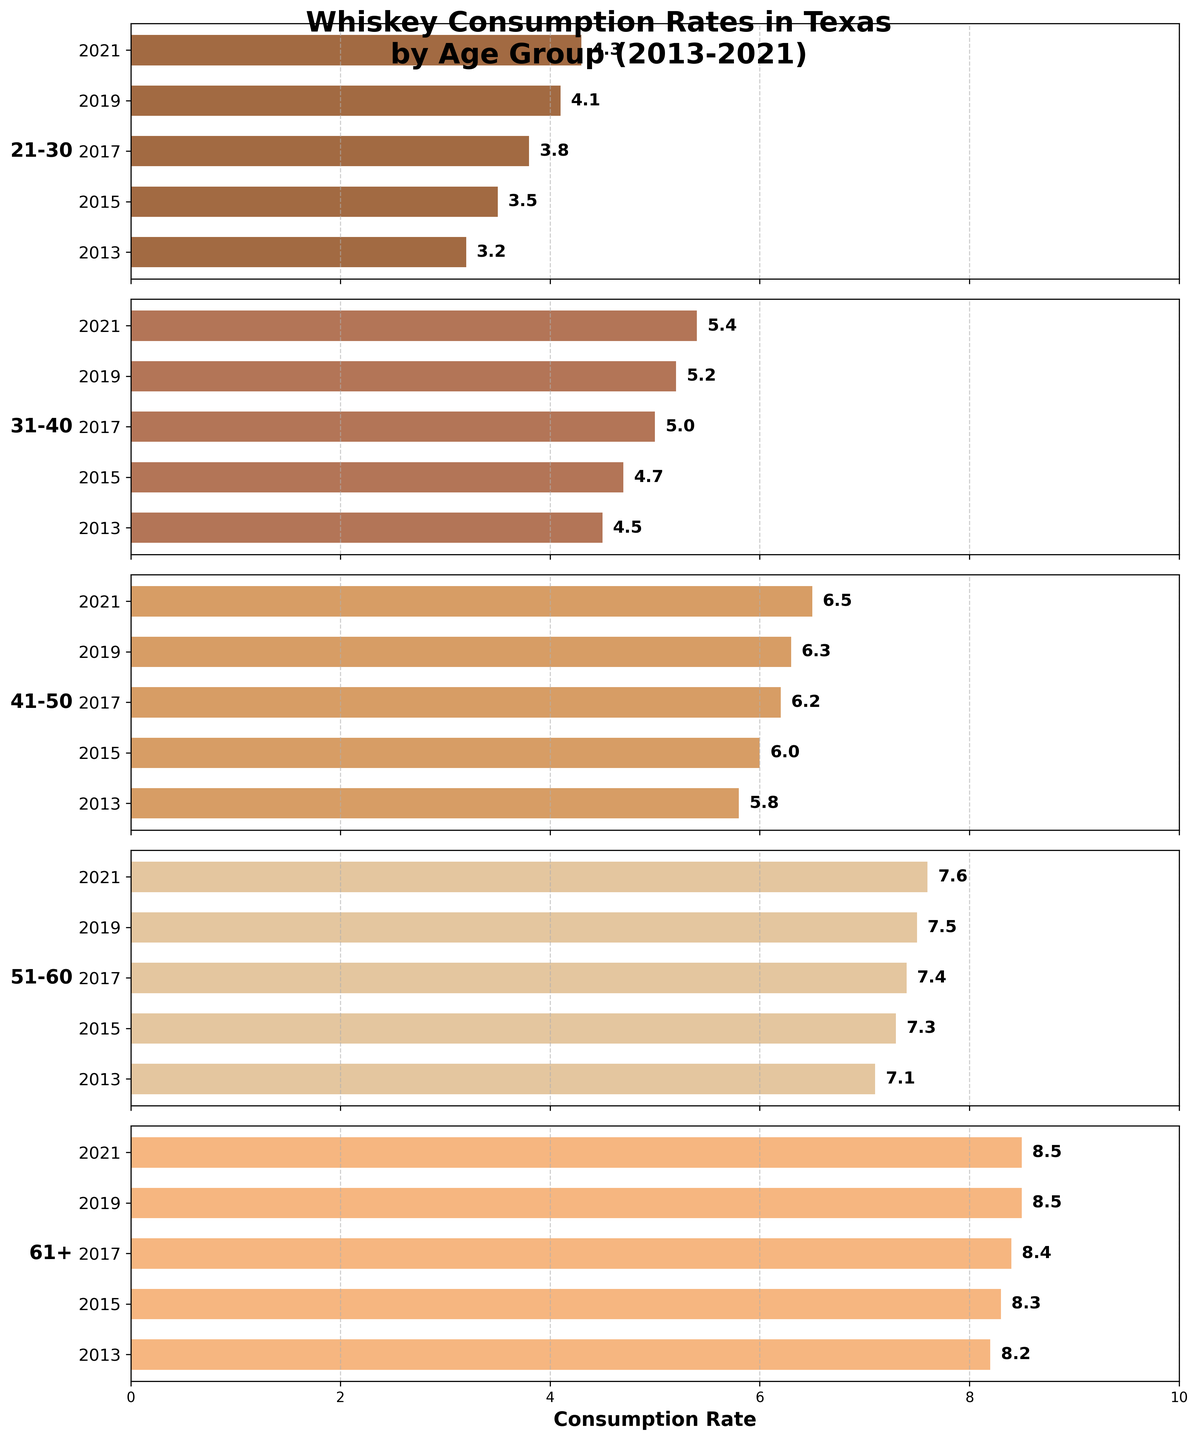What's the title of the figure? The title is displayed at the top of the figure, describing the contents of the graph.
Answer: "Whiskey Consumption Rates in Texas by Age Group (2013-2021)" Which age group had the highest whiskey consumption rate in 2013? By observing the value bars for each age group in 2013, the age group with the longest bar had the highest rate. The 61+ age group has the longest bar in 2013.
Answer: 61+ What is the overall trend in whiskey consumption for the 21-30 age group? The bars for the 21-30 age group show how the values change over the years. They consistently increase from 2013 to 2021.
Answer: Increasing Which year had the highest average consumption rate among all age groups? To find the average, sum the values of all age groups for each year and then divide by the number of age groups. The year with the highest average will be the answer. Sum 2013: 3.2 + 4.5 + 5.8 + 7.1 + 8.2 = 28.8 Sum 2021: 4.3 + 5.4 + 6.5 + 7.6 + 8.5 = 32.3 Average 2021: 32.3 / 5 = 6.46 It's clear that 2021 has the highest average consumption rate.
Answer: 2021 How does the whiskey consumption rate of the 51-60 age group in 2021 compare to that of the 31-40 age group in 2015? Compare the height of the bars corresponding to these data points: 7.6 for 51-60 in 2021 and 4.7 for 31-40 in 2015. 7.6 is greater than 4.7.
Answer: Higher Which age group shows the least variation in whiskey consumption rates over the years? Variation can be measured by the range (max - min value). Calculate for each group:
21-30: 4.3 - 3.2 = 1.1, 31-40: 5.4 - 4.5 = 0.9, 41-50: 6.5 - 5.8 = 0.7, 51-60: 7.6 - 7.1 = 0.5, 61+: 8.5 - 8.2 = 0.3 The 61+ age group has the least variation.
Answer: 61+ What was the whiskey consumption rate for the 41-50 age group in 2019? Locate the bar for the 41-50 age group corresponding to 2019. It reads as 6.3.
Answer: 6.3 Which age group had a noticeable increase in whiskey consumption between 2017 and 2019? Check the difference in bar lengths for each age group between 2017 and 2019. The 21-30 age group shows an increase from 3.8 to 4.1.
Answer: 21-30 What's the difference in whiskey consumption rates between the 31-40 age group and the 61+ age group in 2021? Compare the bars in 2021: 5.4 for 31-40 and 8.5 for 61+. Difference is 8.5 - 5.4.
Answer: 3.1 Which age group consistently showed an increasing trend without any decrease? Look for the age group whose consumption rate steadily rises in each subsequent year from 2013 to 2021. Both 21-30 and 31-40 show steady increases, but any other group like 41-50, 51-60, and 61+ have irregularities.
Answer: 21-30, 31-40 